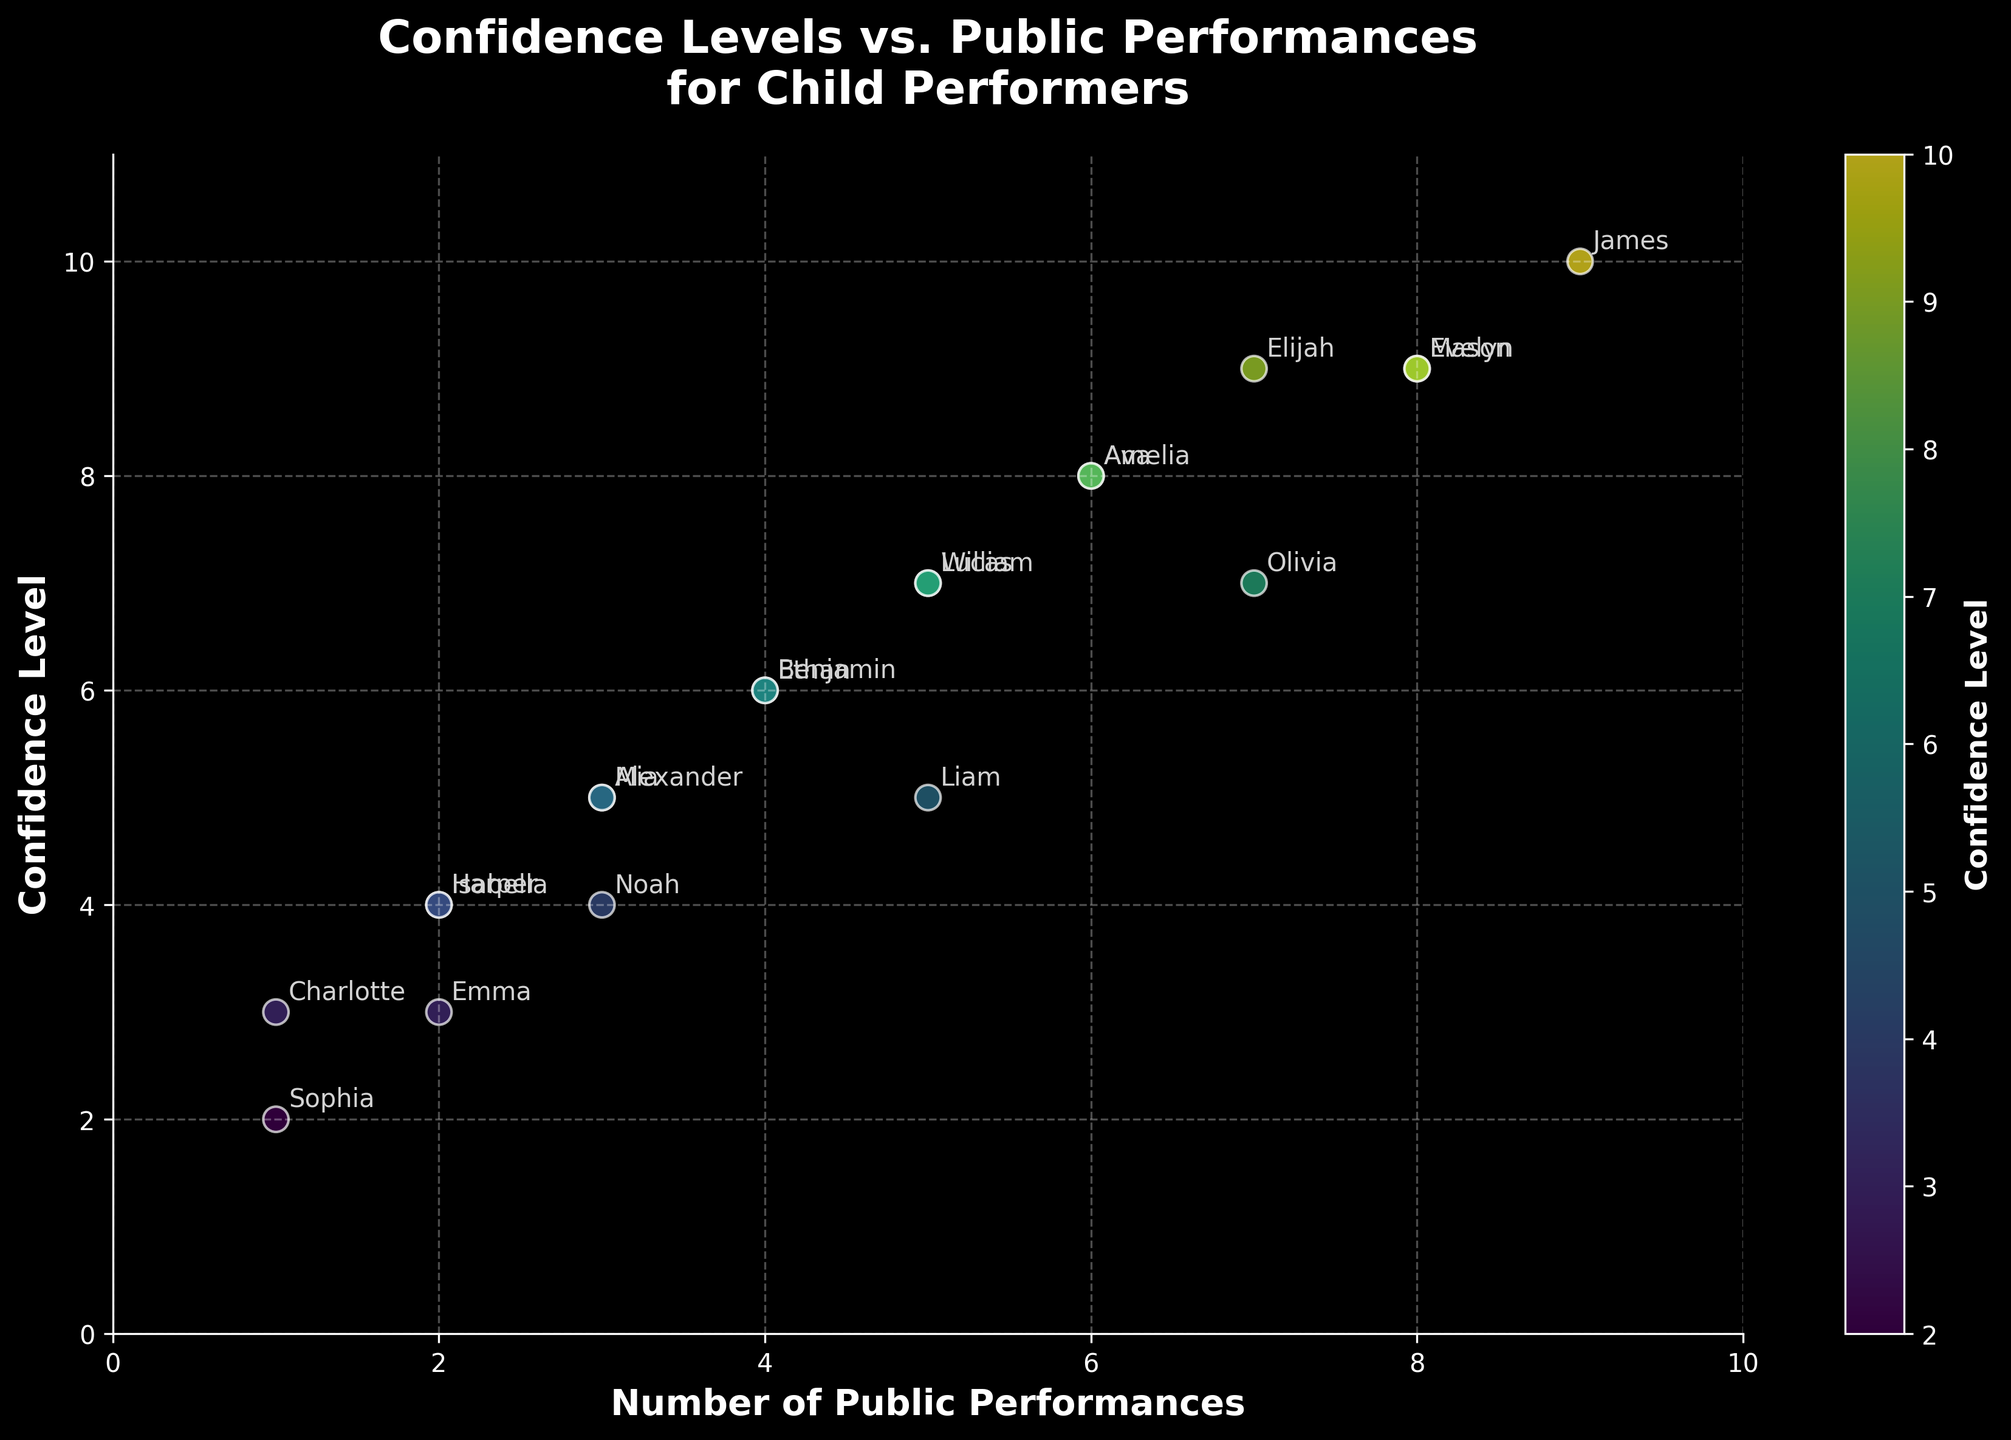What is the title of the plot? The title can be seen at the top of the plot, usually in bold font. It reads "Confidence Levels vs. Public Performances for Child Performers".
Answer: Confidence Levels vs. Public Performances for Child Performers What are the axis labels on the plot? The x-axis label is "Number of Public Performances" and the y-axis label is "Confidence Level". These labels can be found along the respective axes.
Answer: Number of Public Performances, Confidence Level How many performers have confidence levels above 8? By examining the y-axis and locating performers with confidence levels above 8, we can count the number of corresponding data points.
Answer: 3 Which performer has the highest confidence level and how many performances have they done? By looking at the topmost data point on the y-axis, we find James at a confidence level of 10 with 9 performances.
Answer: James, 9 How does Emma’s confidence level compare to Charlotte’s? Emma has a confidence level of 3 with 2 performances. Charlotte has a confidence level of 3 with 1 performance. Both have the same confidence level.
Answer: Same What is the average confidence level of performers who have done exactly 5 performances? The performers are Liam, William, and Lucas with confidence levels of 5, 7, and 7 respectively. The average is calculated as (5 + 7 + 7) / 3 = 6.33.
Answer: 6.33 What is the cluster of performers with the highest number of performances? By examining the x-axis, it can be seen that the highest cluster occurs around the 5 to 8 performances range.
Answer: 5-8 performances If you were to draw a trend line, what would be the general direction (upward or downward)? The general direction would be upward, indicating that confidence levels tend to increase with the number of public performances.
Answer: Upward Which performer has the lowest number of public performances and what is their confidence level? By looking at the leftmost data point on the x-axis, we find Sophia with 1 performance and a confidence level of 2.
Answer: Sophia, 2 